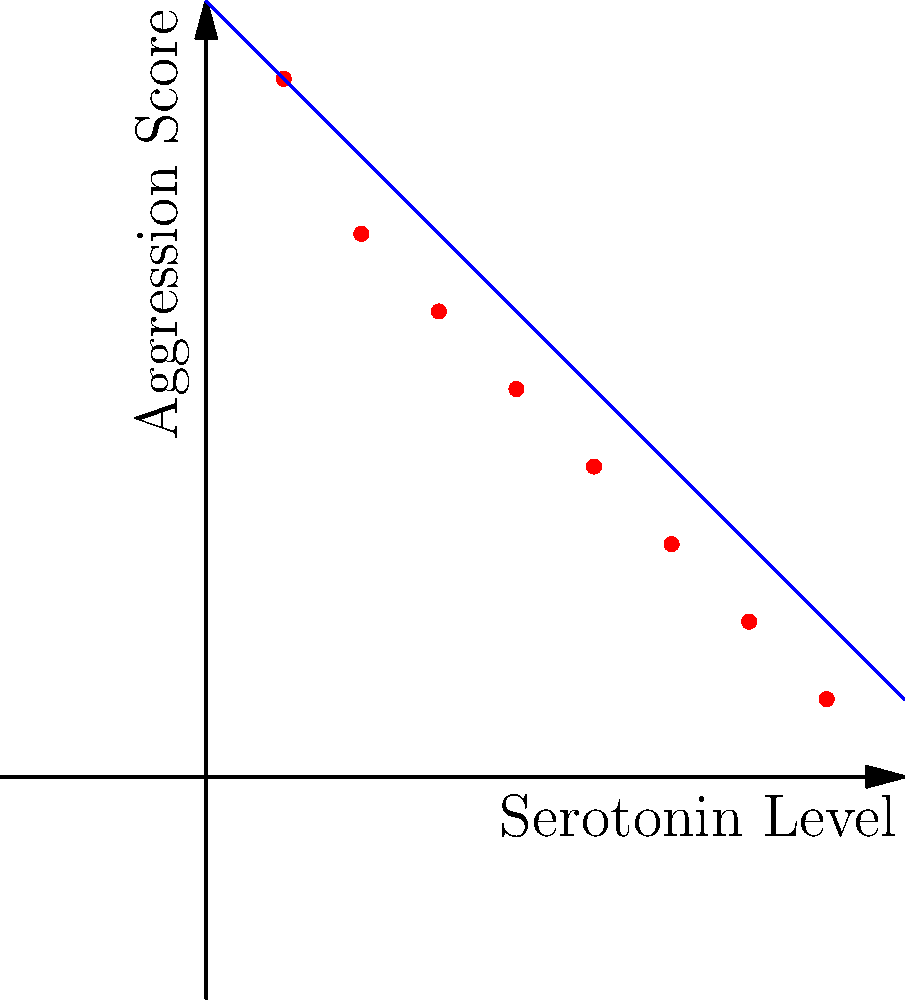Analyze the scatter plot showing the relationship between serotonin levels and aggression scores in adolescents. What type of correlation does this data suggest, and how might this information be clinically relevant in adolescent psychiatry? To analyze this scatter plot and its clinical relevance, let's follow these steps:

1. Observe the overall pattern:
   The points form a clear downward trend from left to right.

2. Identify the correlation type:
   As serotonin levels increase, aggression scores decrease. This indicates a negative (inverse) correlation.

3. Assess the strength of the correlation:
   The points closely follow a straight line, suggesting a strong correlation.

4. Quantify the relationship:
   The best-fit line appears to follow the equation $y = 10 - x$, where $y$ is the aggression score and $x$ is the serotonin level.

5. Clinical relevance in adolescent psychiatry:
   a) This data supports the hypothesis that serotonin plays a role in regulating aggressive behavior.
   b) Lower serotonin levels are associated with higher aggression scores, which aligns with the serotonin deficiency theory of aggression.
   c) This information could guide treatment approaches:
      - Medications that increase serotonin (e.g., SSRIs) might help reduce aggressive behavior.
      - Non-pharmacological interventions that naturally boost serotonin (e.g., exercise, diet changes) could be beneficial.
   d) The strong correlation suggests that serotonin levels could potentially be used as a biomarker for aggression risk in adolescents.
   e) This data could inform early intervention strategies for adolescents with low serotonin levels to prevent aggressive behavior.

6. Limitations to consider:
   a) Correlation does not imply causation; other factors may influence both serotonin levels and aggression.
   b) Individual variations may exist, and this relationship may not apply uniformly to all adolescents.
   c) The sample size and demographic information are not provided, which may limit generalizability.

Understanding this relationship can help in developing more targeted and effective interventions for managing aggressive behavior in adolescents, potentially improving clinical outcomes in child and adolescent psychiatry.
Answer: Strong negative correlation; lower serotonin levels associated with higher aggression, informing potential treatment strategies and early intervention in adolescent psychiatry. 